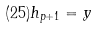<formula> <loc_0><loc_0><loc_500><loc_500>( 2 5 ) h _ { p + 1 } = y</formula> 